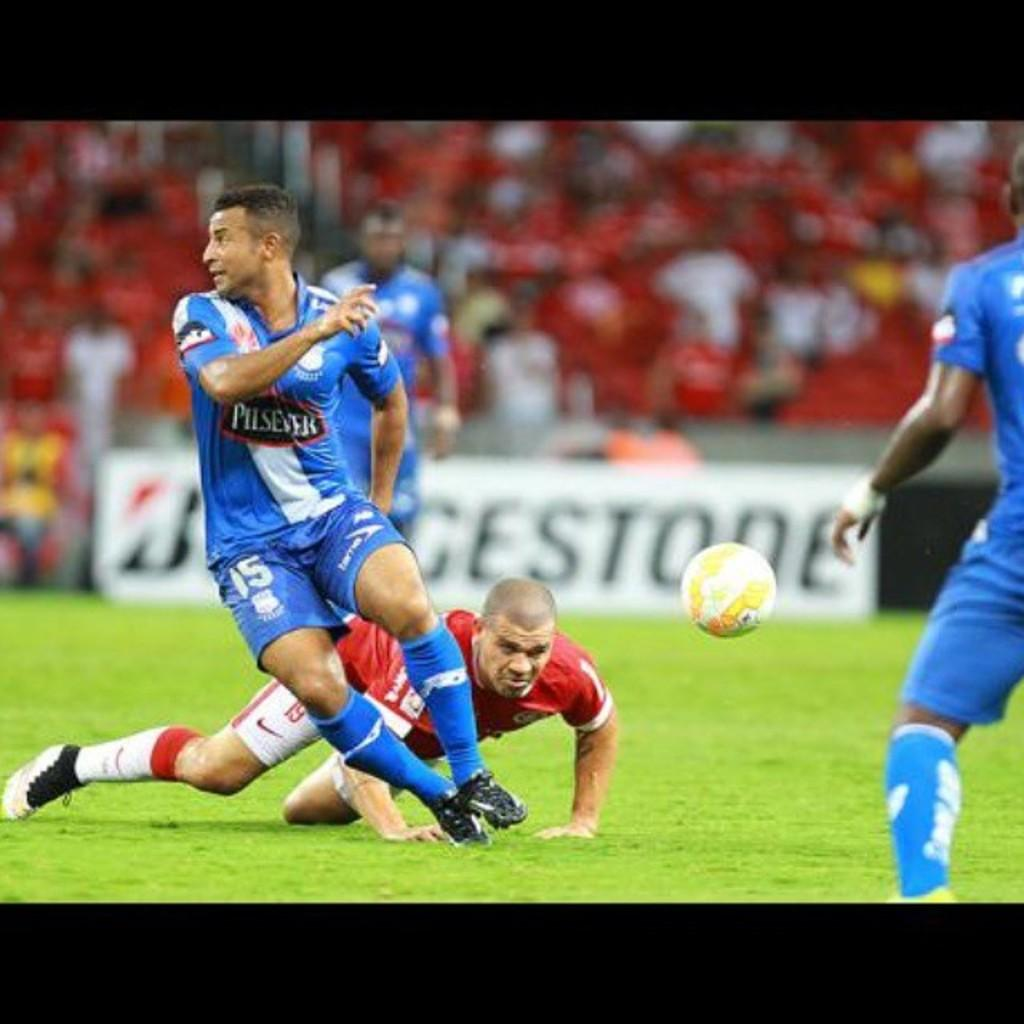<image>
Offer a succinct explanation of the picture presented. Action at a soccer game sponsored by Bridgestone as one player falls to the ground. 